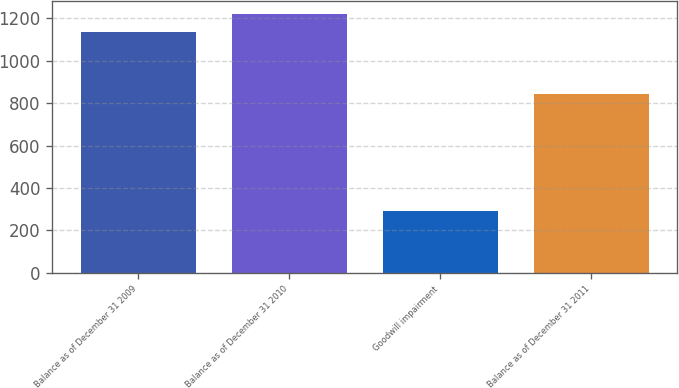<chart> <loc_0><loc_0><loc_500><loc_500><bar_chart><fcel>Balance as of December 31 2009<fcel>Balance as of December 31 2010<fcel>Goodwill impairment<fcel>Balance as of December 31 2011<nl><fcel>1134<fcel>1218.4<fcel>290<fcel>844<nl></chart> 